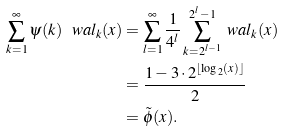<formula> <loc_0><loc_0><loc_500><loc_500>\sum _ { k = 1 } ^ { \infty } \psi ( k ) \ w a l _ { k } ( x ) & = \sum _ { l = 1 } ^ { \infty } \frac { 1 } { 4 ^ { l } } \sum _ { k = 2 ^ { l - 1 } } ^ { 2 ^ { l } - 1 } \ w a l _ { k } ( x ) \\ & = \frac { 1 - 3 \cdot 2 ^ { \lfloor \log _ { 2 } ( x ) \rfloor } } { 2 } \\ & = \tilde { \phi } ( x ) .</formula> 